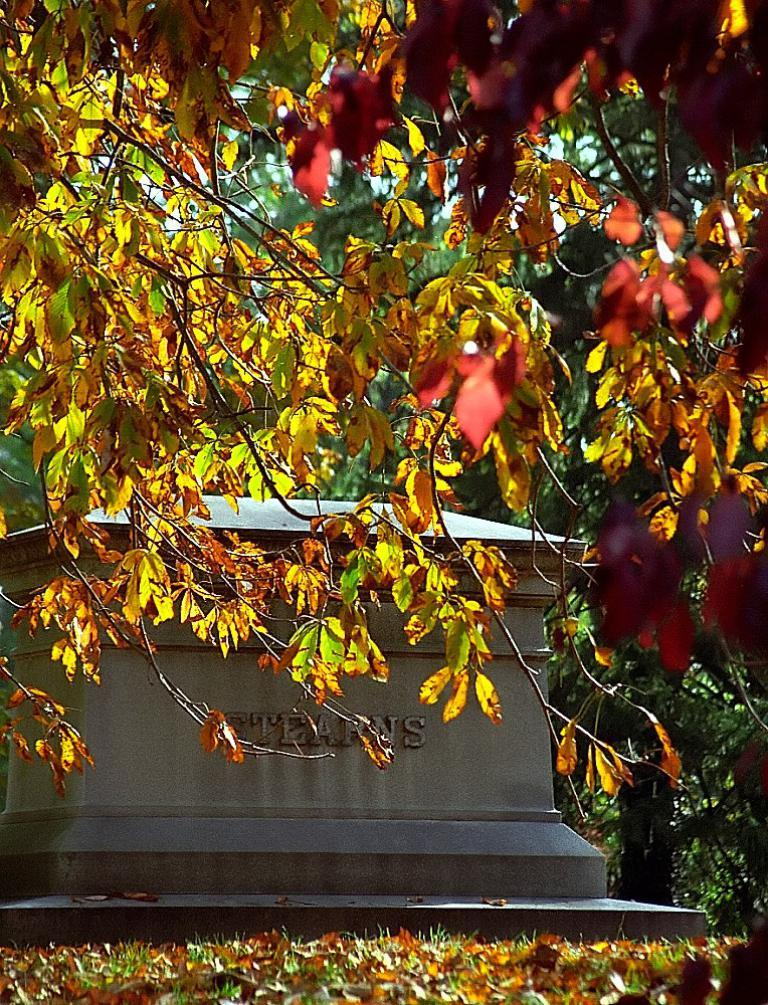What type of vegetation can be seen in the image? There are branches of trees with leaves in the image. What else is visible in the image besides the vegetation? There is a wall visible in the image. What is present on the ground in the image? Dried leaves are present on the ground in the image. Who is the representative of the hand in the image? There is no hand present in the image. 